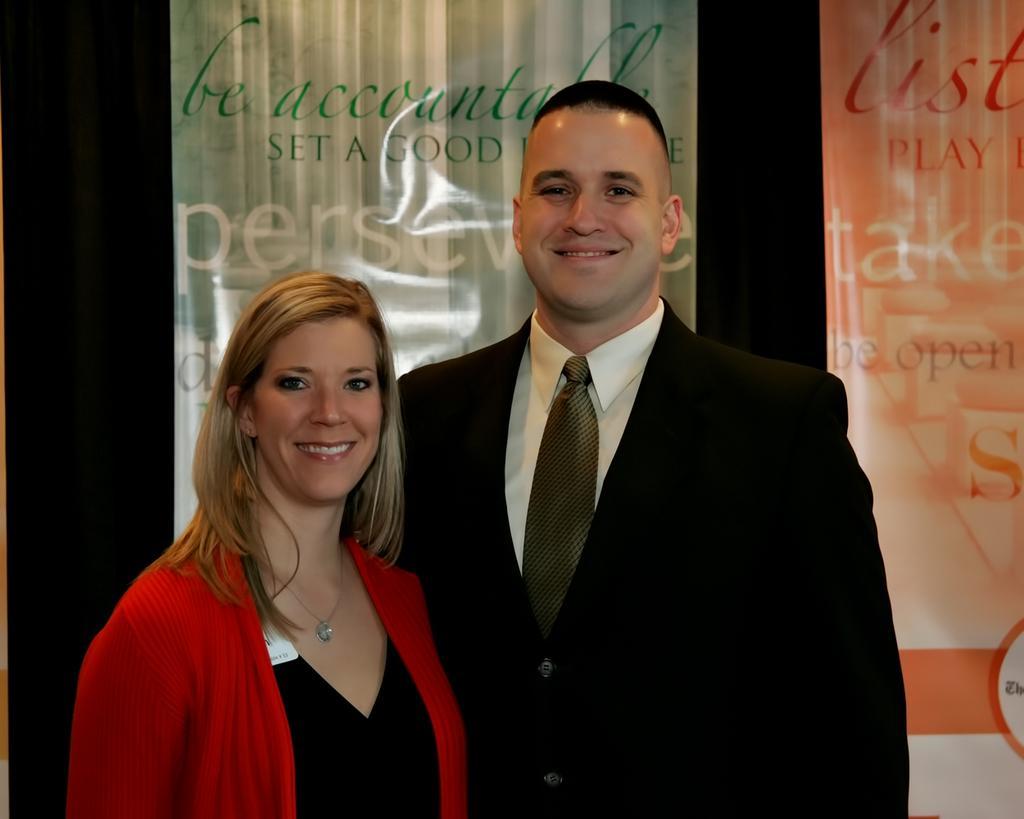Can you describe this image briefly? In this image we can see two people standing. And in the background, we can see the board/banner with some text on it. 